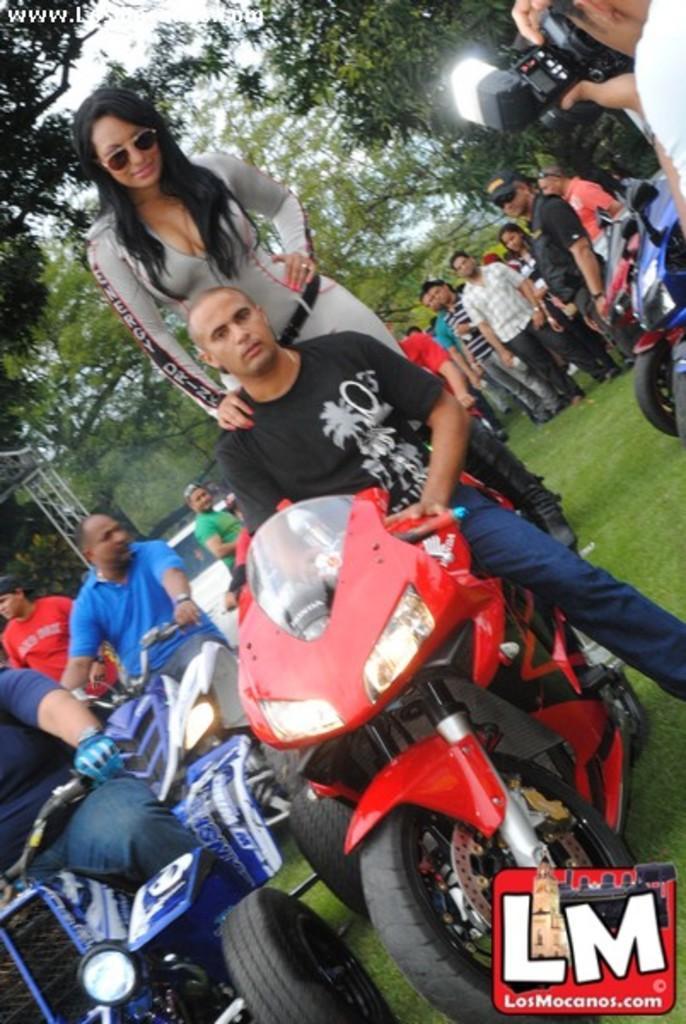Could you give a brief overview of what you see in this image? In this image I see 3 men who are sitting on the vehicles and this woman is standing on the bike and I can also see there is a person with the camera. In the background I see trees, lot of people and the bikes. 